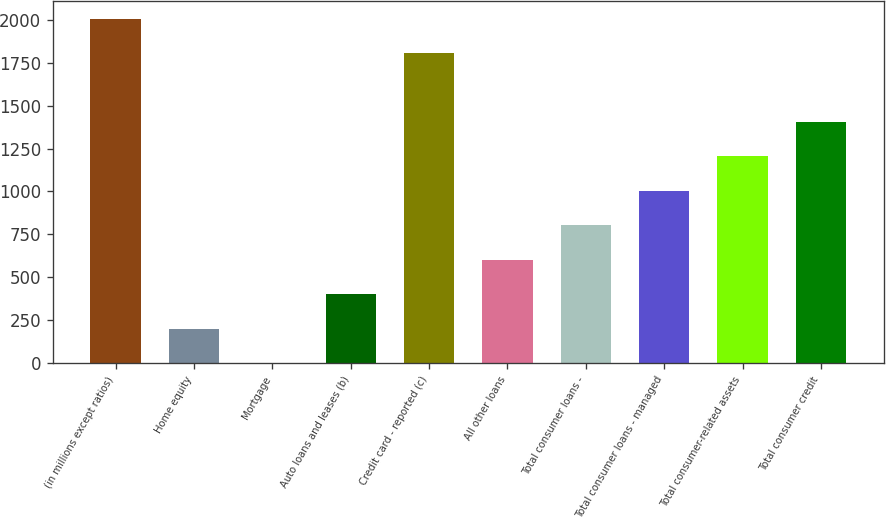<chart> <loc_0><loc_0><loc_500><loc_500><bar_chart><fcel>(in millions except ratios)<fcel>Home equity<fcel>Mortgage<fcel>Auto loans and leases (b)<fcel>Credit card - reported (c)<fcel>All other loans<fcel>Total consumer loans -<fcel>Total consumer loans - managed<fcel>Total consumer-related assets<fcel>Total consumer credit<nl><fcel>2007<fcel>201.1<fcel>0.45<fcel>401.75<fcel>1806.32<fcel>602.4<fcel>803.05<fcel>1003.7<fcel>1204.36<fcel>1405.01<nl></chart> 